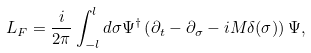<formula> <loc_0><loc_0><loc_500><loc_500>L _ { F } = \frac { i } { 2 \pi } \int _ { - l } ^ { l } d \sigma \Psi ^ { \dagger } \left ( \partial _ { t } - \partial _ { \sigma } - i { M } \delta ( \sigma ) \right ) \Psi ,</formula> 